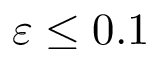Convert formula to latex. <formula><loc_0><loc_0><loc_500><loc_500>\varepsilon \leq 0 . 1</formula> 